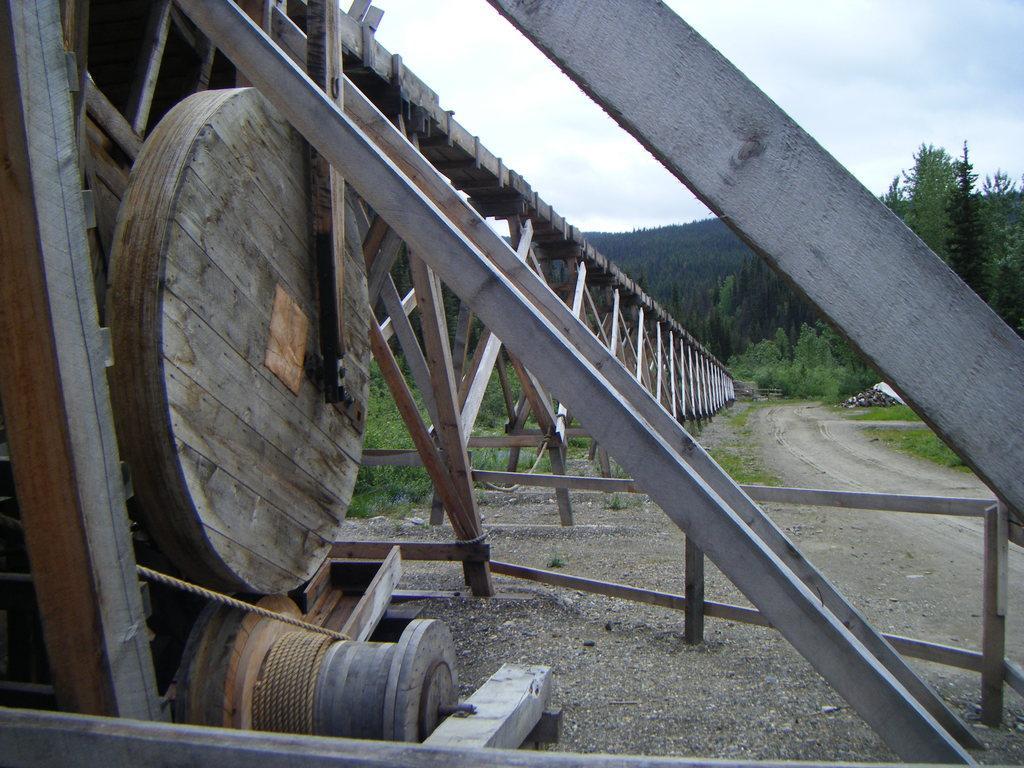Describe this image in one or two sentences. In this picture we can see the road, trees, stones, rope, fence and in the background we can see the sky with clouds. 